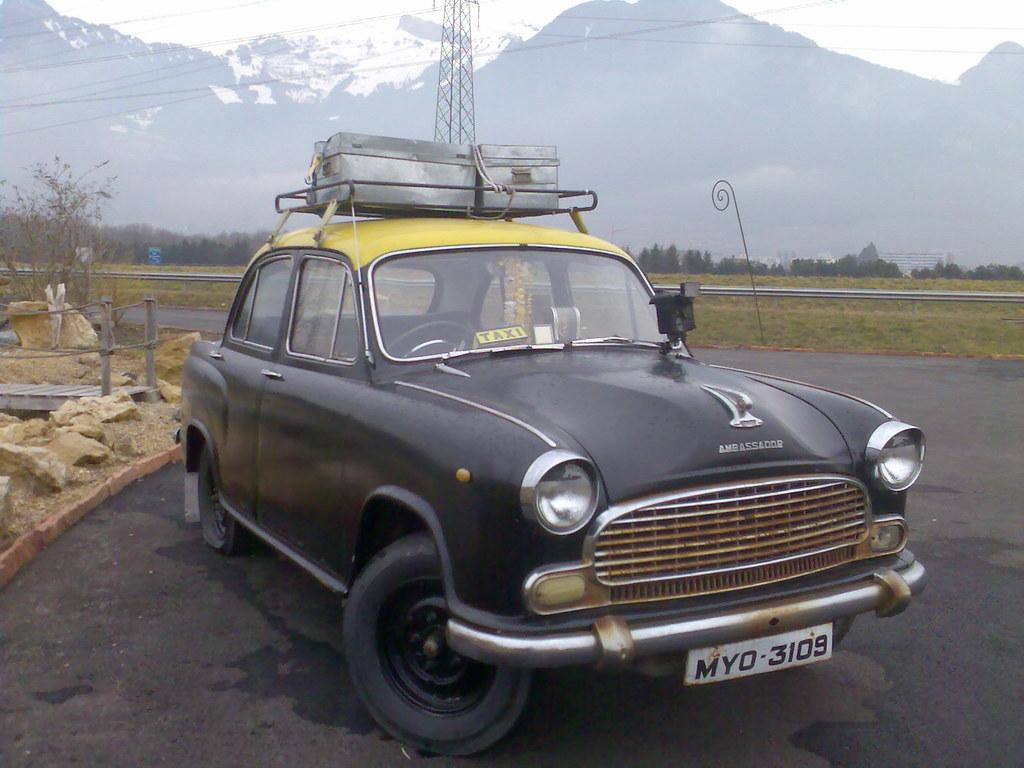What is the main subject of the image? There is a car in the image. Where is the car located? The car is on the road. What type of natural elements can be seen in the image? There are trees, plants, mountains, and rocks in the image. What man-made structure is present in the image? There is a tower in the image. What type of hat is the ant wearing in the image? There is no ant or hat present in the image. How many stars can be seen in the sky in the image? There is no sky visible in the image, so it is not possible to determine the number of stars. 